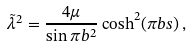<formula> <loc_0><loc_0><loc_500><loc_500>\tilde { \lambda } ^ { 2 } = \frac { 4 \mu } { \sin \pi b ^ { 2 } } \cosh ^ { 2 } ( \pi b s ) \, ,</formula> 